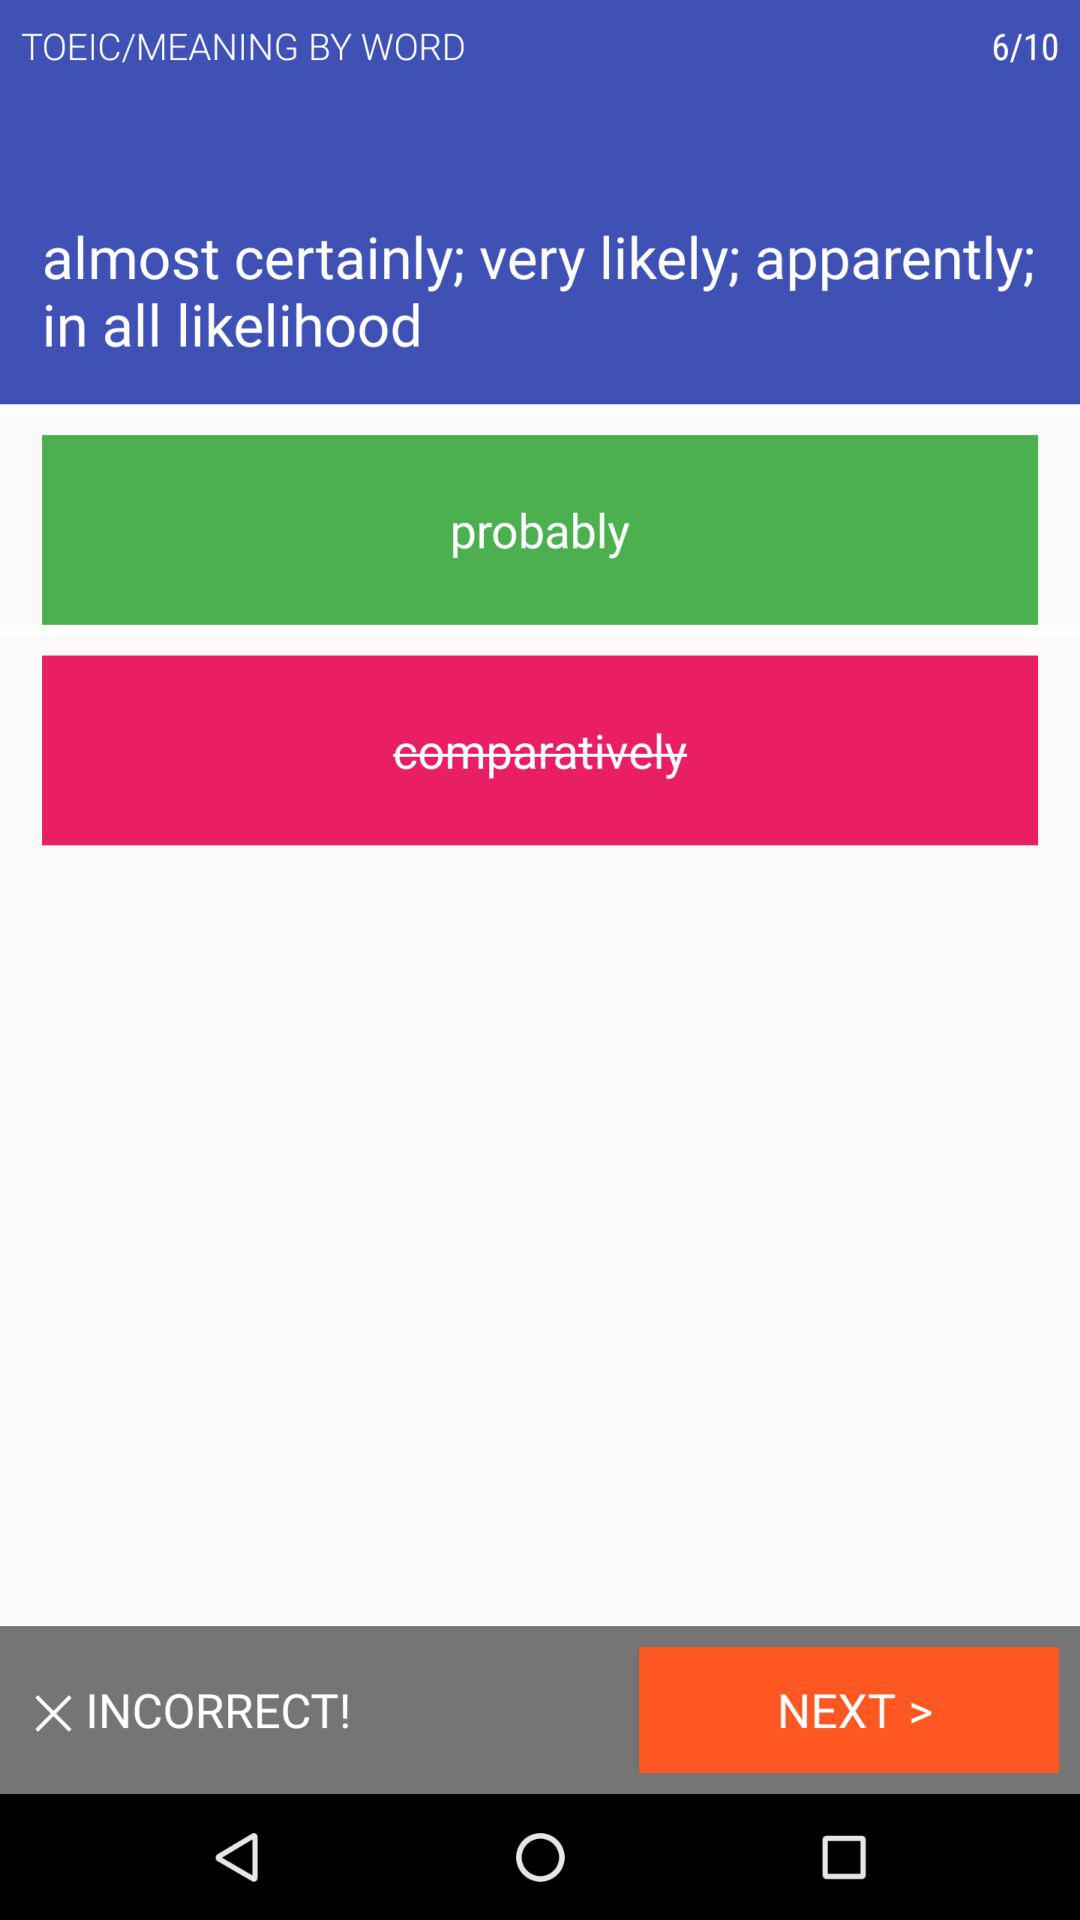At which question am I? You are at sixth question. 